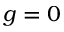Convert formula to latex. <formula><loc_0><loc_0><loc_500><loc_500>g = 0</formula> 